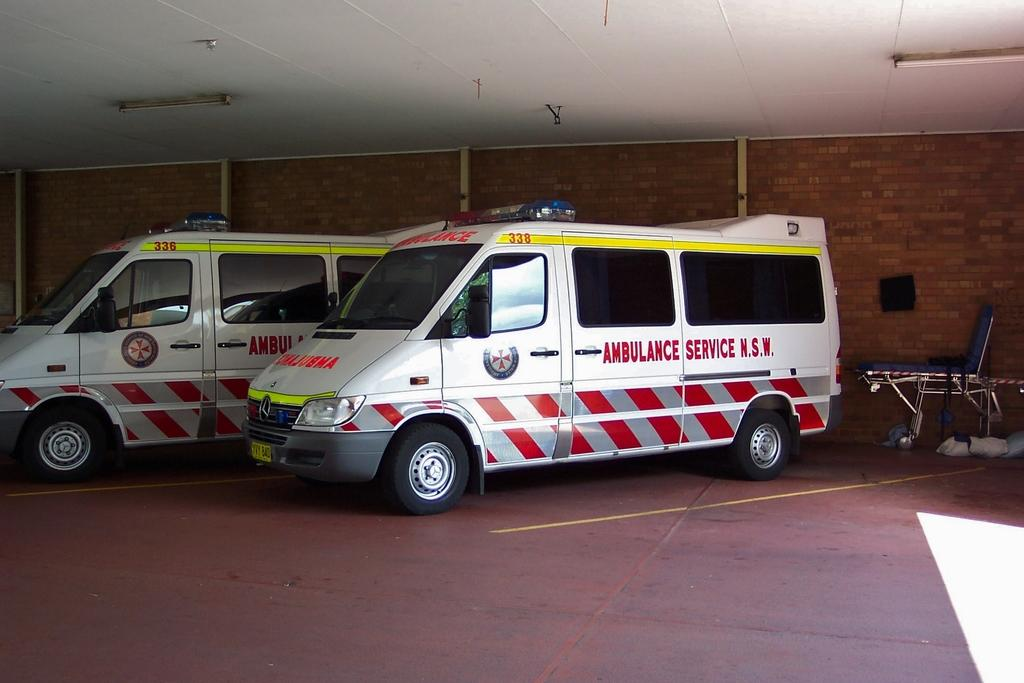<image>
Write a terse but informative summary of the picture. A couple of white vans that are maked Ambulance Service. 